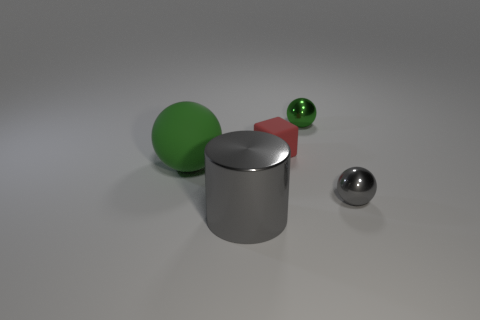Are there any other things that have the same color as the large cylinder?
Give a very brief answer. Yes. There is a gray object that is the same size as the cube; what shape is it?
Provide a succinct answer. Sphere. Are there any things of the same color as the big sphere?
Make the answer very short. Yes. There is a big cylinder; does it have the same color as the metal sphere that is in front of the small red block?
Give a very brief answer. Yes. What is the color of the big sphere that is behind the gray metal thing left of the red matte object?
Provide a short and direct response. Green. Is there a small gray shiny thing to the left of the green ball that is on the right side of the green ball left of the big gray metal thing?
Your answer should be very brief. No. What is the color of the object that is the same material as the small red cube?
Your answer should be compact. Green. How many gray cylinders have the same material as the small gray thing?
Provide a succinct answer. 1. Do the tiny red object and the green object that is behind the tiny red matte cube have the same material?
Offer a very short reply. No. What number of things are either tiny things behind the tiny gray thing or tiny balls?
Provide a short and direct response. 3. 